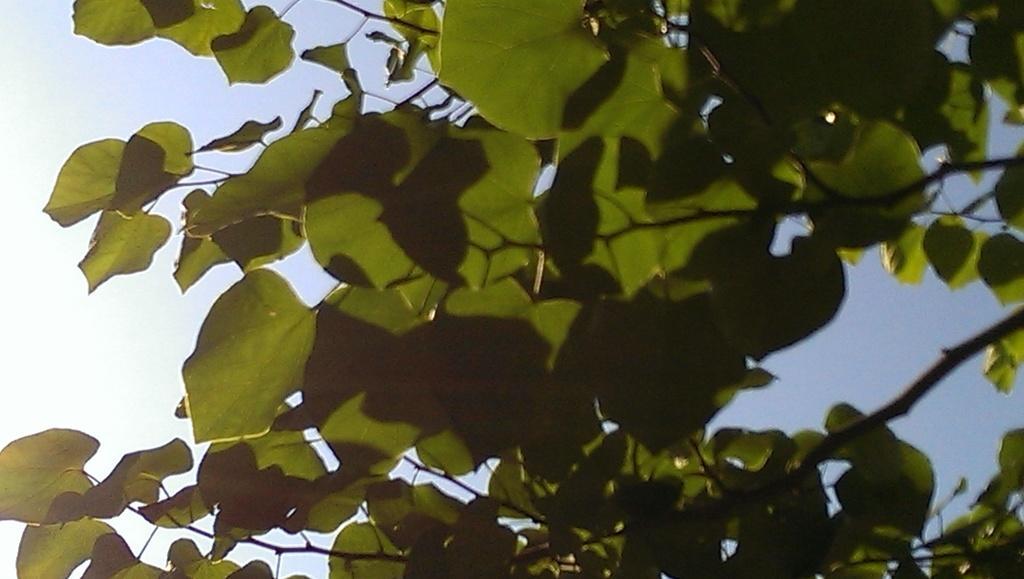Please provide a concise description of this image. In this image I can see there is a tree and at the back there is a sky. 